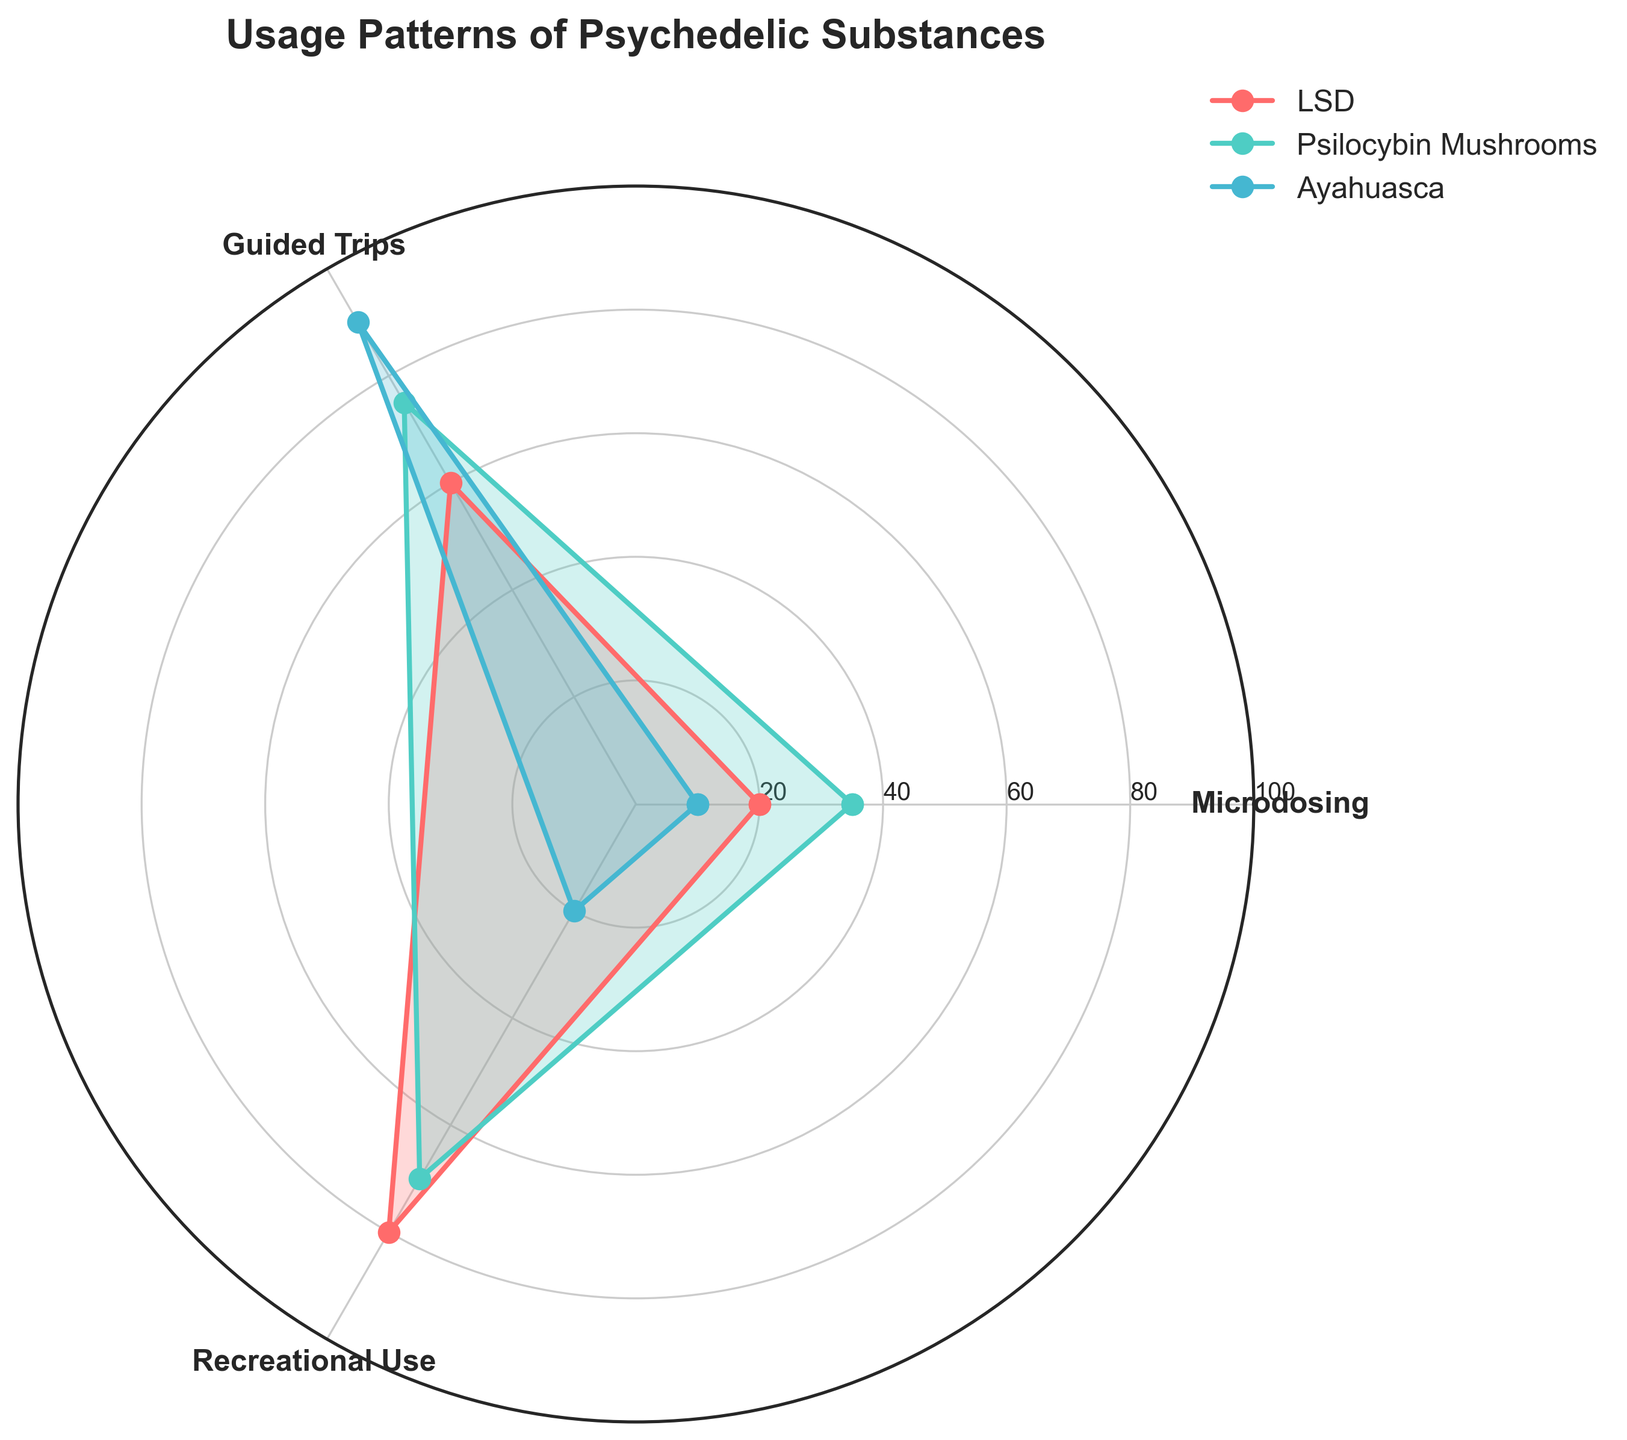what are the three psychedelic substances shown in the figure? The title indicates that the chart is about Usage Patterns of Psychedelic Substances, and the legend identifies the three substances. These substances are LSD, Psilocybin Mushrooms, and Ayahuasca.
Answer: LSD, Psilocybin Mushrooms, and Ayahuasca Which psychedelic substance has the highest value for Guided Trips? By observing the lengths of the spokes corresponding to Guided Trips, Psilocybin Mushrooms reach the highest value.
Answer: Psilocybin Mushrooms What is the average value for Microdosing across all three substances? The values for Microdosing are 20 for LSD, 35 for Psilocybin Mushrooms, and 10 for Ayahuasca. Add these values and divide by 3: (20 + 35 + 10) / 3 = 65 / 3.
Answer: 21.67 How do the Recreational Use values for LSD and Ayahuasca compare? LSD has a Recreational Use value of 80, while Ayahuasca has 20. Comparing these values, LSD is higher.
Answer: LSD is higher Which category has the most balanced usage across all three substances? By visually comparing the spreads of the values for each category, Microdosing appears to have the smallest differences between the substances.
Answer: Microdosing Which substance has the least usage in any category? By observing the smallest data points, Ayahuasca has the least usage in the Microdosing category with a value of 10.
Answer: Ayahuasca in Microdosing For LSD, what is the difference in usage between Guided Trips and Recreational Use? The values for LSD are 60 for Guided Trips and 80 for Recreational Use. The difference is 80 - 60.
Answer: 20 What's the sum of the values for Psilocybin Mushrooms across all categories? The values for Psilocybin Mushrooms are 35 for Microdosing, 75 for Guided Trips, and 70 for Recreational Use. Sum them up: 35 + 75 + 70 = 180.
Answer: 180 